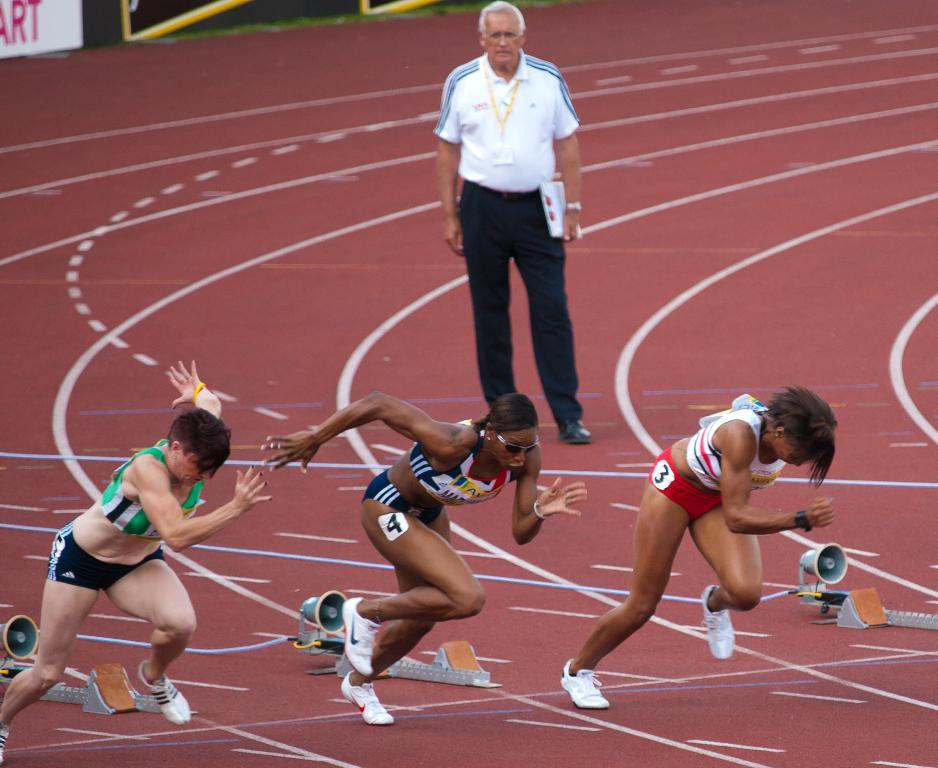What are the people in the image doing? The people in the image are running. What can be seen in the foreground area of the image? There are objects in the foreground area of the image. What type of signage is present in the image? There are posters in the image. Can you describe the man's position in the image? There is a man standing in the background of the image. What type of vase is located on the edge of the image? There is no vase present in the image, and therefore no such object can be found on the edge. 